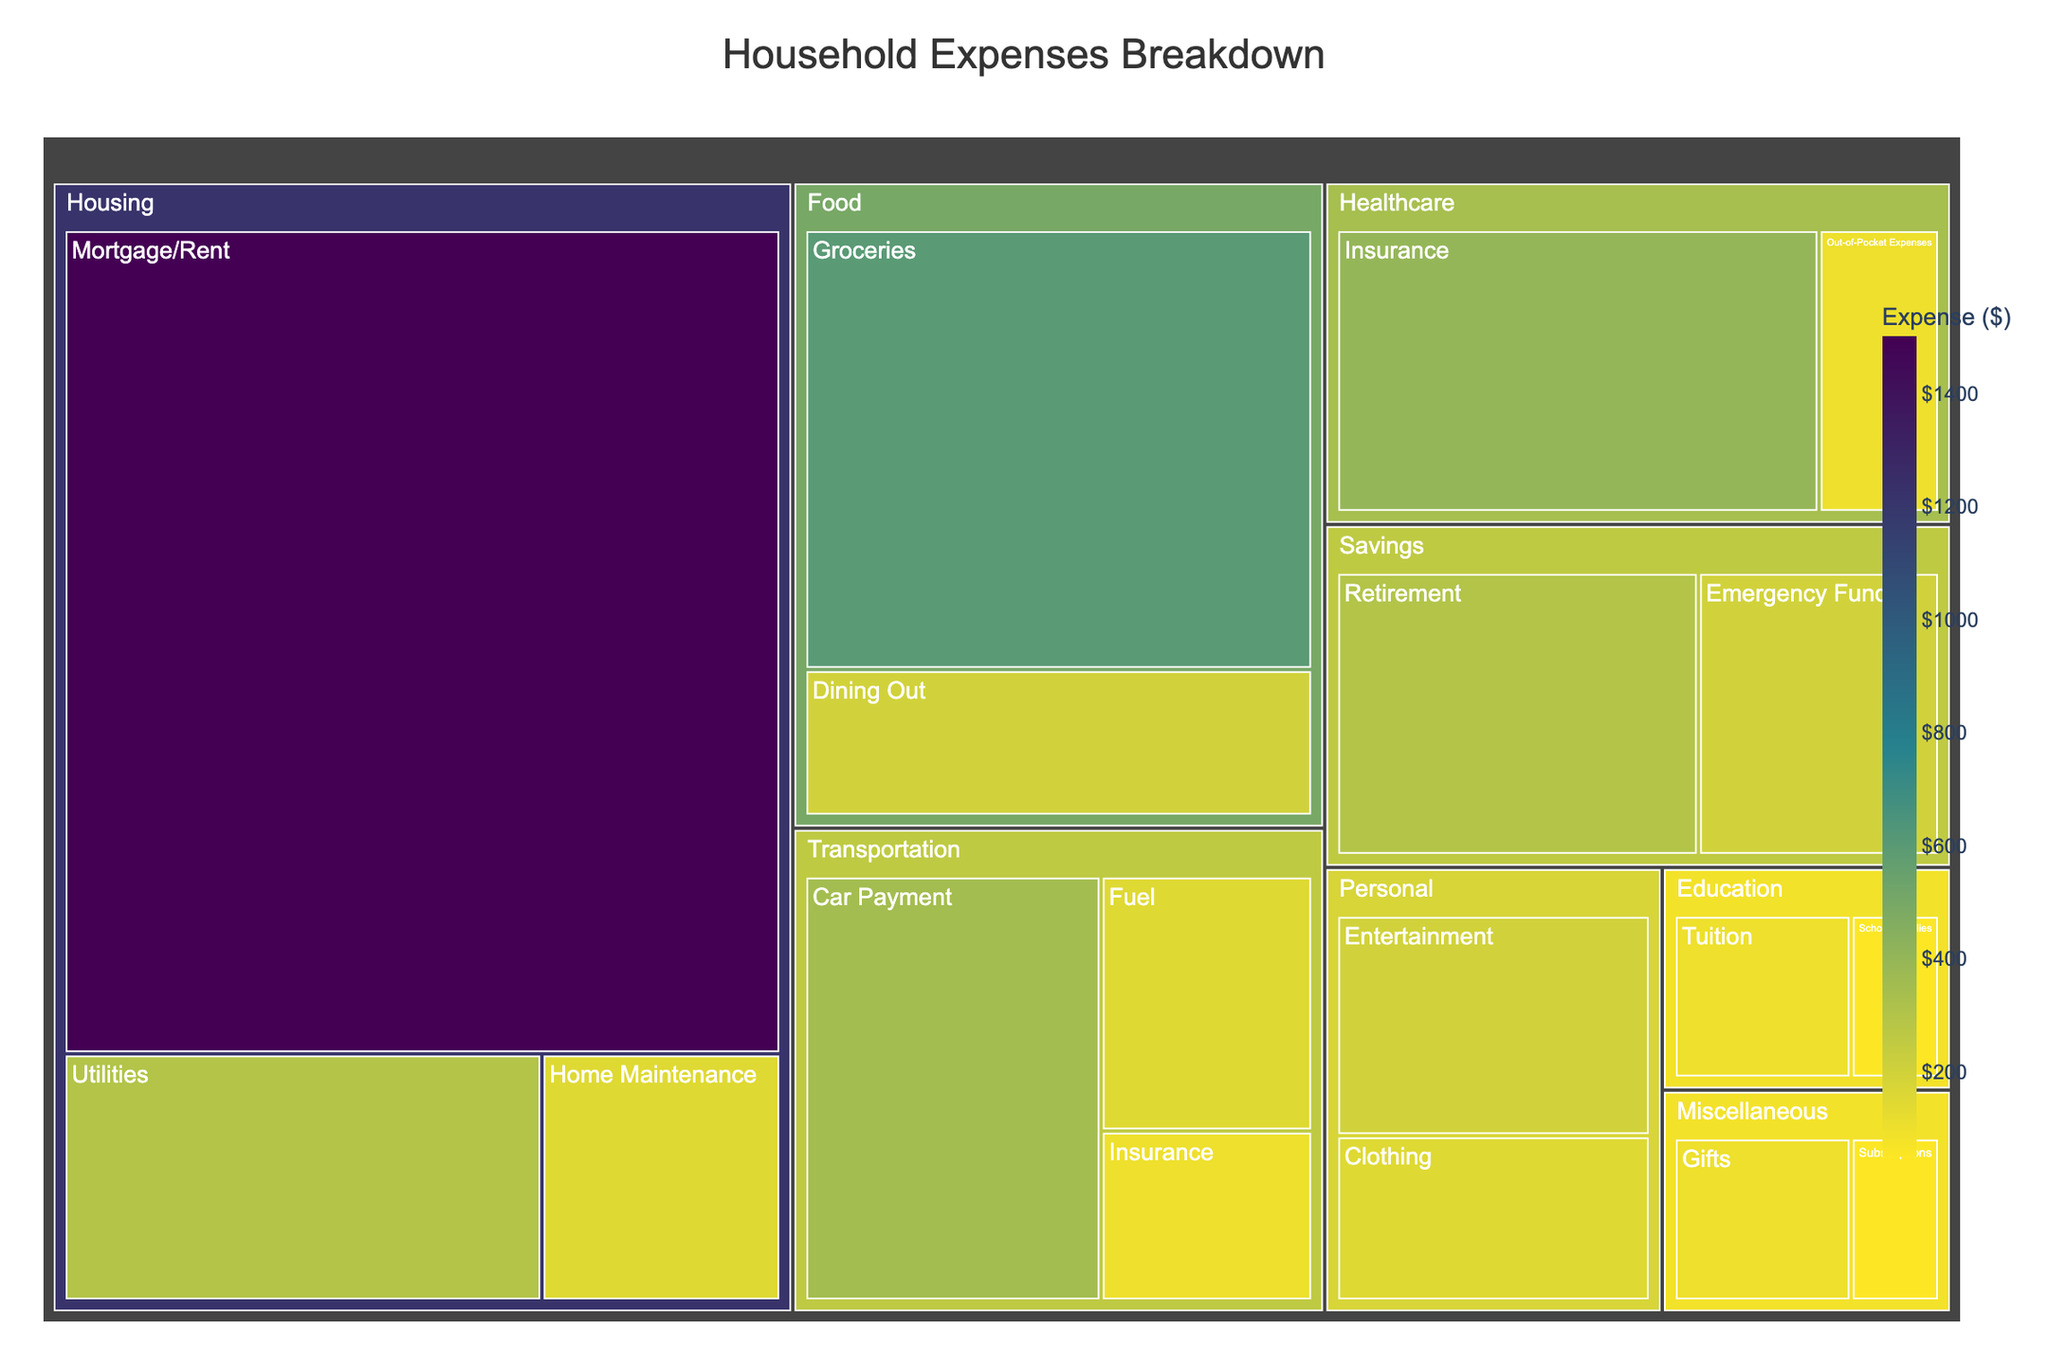Which subcategory has the highest expense? The subcategory with the highest expense can be identified by looking for the largest area or the amount in the figure. The 'Mortgage/Rent' section in the Housing category has an expense of $1500, which is the highest among all subcategories.
Answer: Mortgage/Rent What is the total expense for the Food category? To find the total expense for the Food category, sum the values of its subcategories. Groceries ($600) + Dining Out ($200) equals $800.
Answer: $800 Which category has the lowest overall expense? The category with the lowest overall expense can be found by comparing the sum of all subcategory expenses within each category. The Education category has the lowest sum with $150 (School Supplies $50 + Tuition $100).
Answer: Education How does the expense for Car Payment compare to Dining Out? To compare these subcategories, look at their values directly. Car Payment has an expense of $350 while Dining Out has $200. Therefore, Car Payment is more expensive than Dining Out by $150.
Answer: Car Payment is $150 more What is the average expense for the subcategories under Healthcare? To calculate the average expense, sum the values of the subcategories under Healthcare (Insurance $400 + Out-of-Pocket Expenses $100) and divide by the number of subcategories. The total is $500, and there are 2 subcategories, so the average is $500/2 = $250.
Answer: $250 Which category has the most subcategories? To determine which category has the most subcategories, count the subcategories for each category. The Housing category has the most with three subcategories (Mortgage/Rent, Utilities, Home Maintenance).
Answer: Housing Are there any categories where the expenses of each subcategory are equal? To find if any category has equal expenses across subcategories, check the values of each subcategory within each category. No category has equal expenses across all its subcategories.
Answer: No What is the combined expense for Housing and Transportation? The combined expense is found by summing the total expenses for Housing and Transportation categories. Housing (Mortgage/Rent $1500 + Utilities $300 + Home Maintenance $150 = $1950) and Transportation (Car Payment $350 + Fuel $150 + Insurance $100 = $600). The combined expense is $1950 + $600 = $2550.
Answer: $2550 Which category's total expense is closest to $1000? Compare the total expenses of each category to $1000. The Miscellaneous category has a total expense of $150 (Subscriptions $50 + Gifts $100), which is the closest total to $1000.
Answer: Miscellaneous What percentage of the total expenses is dedicated to Savings? First, find the total expenses across all categories, then calculate the percentage for Savings. Total expense is $6000 (sum of all subcategories' values). Savings has an expense of $500 (Emergency Fund $200 + Retirement $300). The percentage is ($500 / $6000) * 100 = ~8.33%.
Answer: ~8.33% 